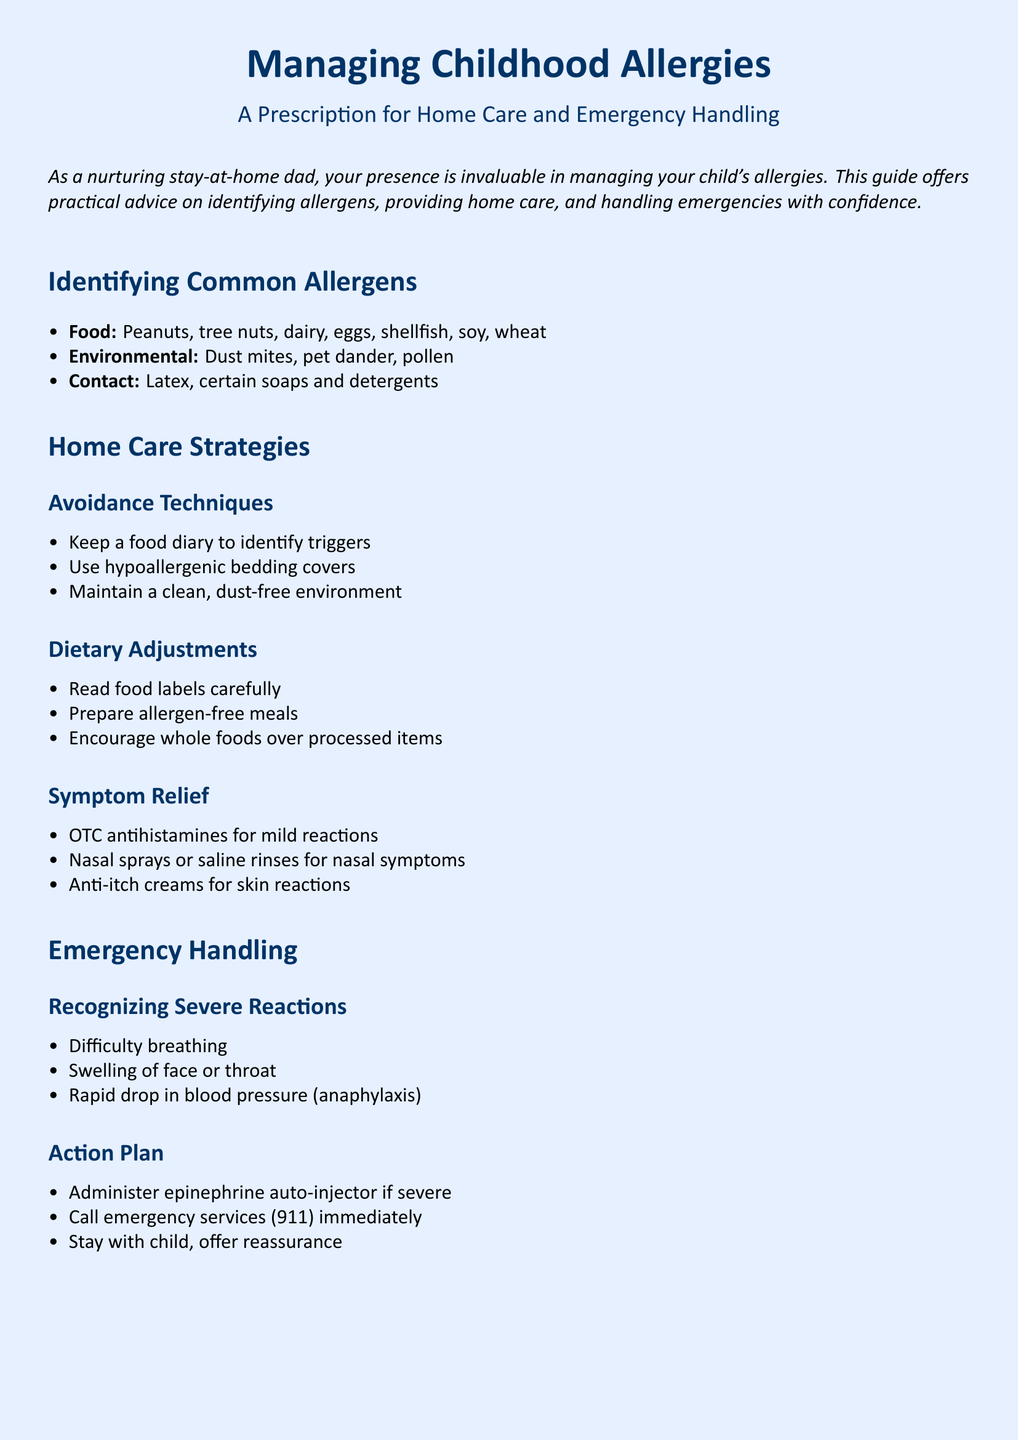what are common food allergens? The document lists specific food allergens commonly affecting children, including peanuts, tree nuts, dairy, eggs, shellfish, soy, and wheat.
Answer: peanuts, tree nuts, dairy, eggs, shellfish, soy, wheat what is a strategy for symptom relief? The document provides a suggestion for dealing with mild allergic reactions, including over-the-counter antihistamines.
Answer: OTC antihistamines what should you do if there is difficulty breathing? The document states the immediate action to take in case of severe allergic reactions, indicating that one should administer an epinephrine auto-injector.
Answer: administer epinephrine auto-injector what dietary adjustment is recommended? The document emphasizes the importance of reading food labels carefully to avoid allergens.
Answer: read food labels carefully what type of aid can help with skin reactions? The document suggests using anti-itch creams for relief from skin symptoms caused by allergies.
Answer: anti-itch creams how should you follow up after an emergency? The document advises that one should follow up with an allergist or pediatrician after an emergency situation.
Answer: follow up with allergist/pediatrician in case of anaphylaxis, who should you call? The document clearly states the need to call emergency services immediately when faced with anaphylaxis.
Answer: emergency services (911) what is recommended to manage dust allergies at home? The document suggests maintaining a clean, dust-free environment as a home care strategy.
Answer: maintain a clean, dust-free environment 